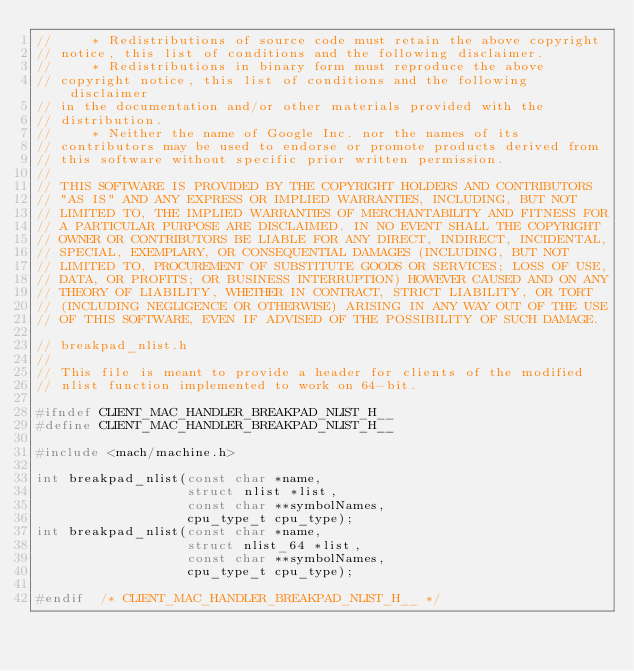Convert code to text. <code><loc_0><loc_0><loc_500><loc_500><_C_>//     * Redistributions of source code must retain the above copyright
// notice, this list of conditions and the following disclaimer.
//     * Redistributions in binary form must reproduce the above
// copyright notice, this list of conditions and the following disclaimer
// in the documentation and/or other materials provided with the
// distribution.
//     * Neither the name of Google Inc. nor the names of its
// contributors may be used to endorse or promote products derived from
// this software without specific prior written permission.
//
// THIS SOFTWARE IS PROVIDED BY THE COPYRIGHT HOLDERS AND CONTRIBUTORS
// "AS IS" AND ANY EXPRESS OR IMPLIED WARRANTIES, INCLUDING, BUT NOT
// LIMITED TO, THE IMPLIED WARRANTIES OF MERCHANTABILITY AND FITNESS FOR
// A PARTICULAR PURPOSE ARE DISCLAIMED. IN NO EVENT SHALL THE COPYRIGHT
// OWNER OR CONTRIBUTORS BE LIABLE FOR ANY DIRECT, INDIRECT, INCIDENTAL,
// SPECIAL, EXEMPLARY, OR CONSEQUENTIAL DAMAGES (INCLUDING, BUT NOT
// LIMITED TO, PROCUREMENT OF SUBSTITUTE GOODS OR SERVICES; LOSS OF USE,
// DATA, OR PROFITS; OR BUSINESS INTERRUPTION) HOWEVER CAUSED AND ON ANY
// THEORY OF LIABILITY, WHETHER IN CONTRACT, STRICT LIABILITY, OR TORT
// (INCLUDING NEGLIGENCE OR OTHERWISE) ARISING IN ANY WAY OUT OF THE USE
// OF THIS SOFTWARE, EVEN IF ADVISED OF THE POSSIBILITY OF SUCH DAMAGE.

// breakpad_nlist.h
//
// This file is meant to provide a header for clients of the modified
// nlist function implemented to work on 64-bit.

#ifndef CLIENT_MAC_HANDLER_BREAKPAD_NLIST_H__
#define CLIENT_MAC_HANDLER_BREAKPAD_NLIST_H__

#include <mach/machine.h>

int breakpad_nlist(const char *name,
                   struct nlist *list,
                   const char **symbolNames,
                   cpu_type_t cpu_type);
int breakpad_nlist(const char *name,
                   struct nlist_64 *list,
                   const char **symbolNames,
                   cpu_type_t cpu_type);

#endif  /* CLIENT_MAC_HANDLER_BREAKPAD_NLIST_H__ */
</code> 